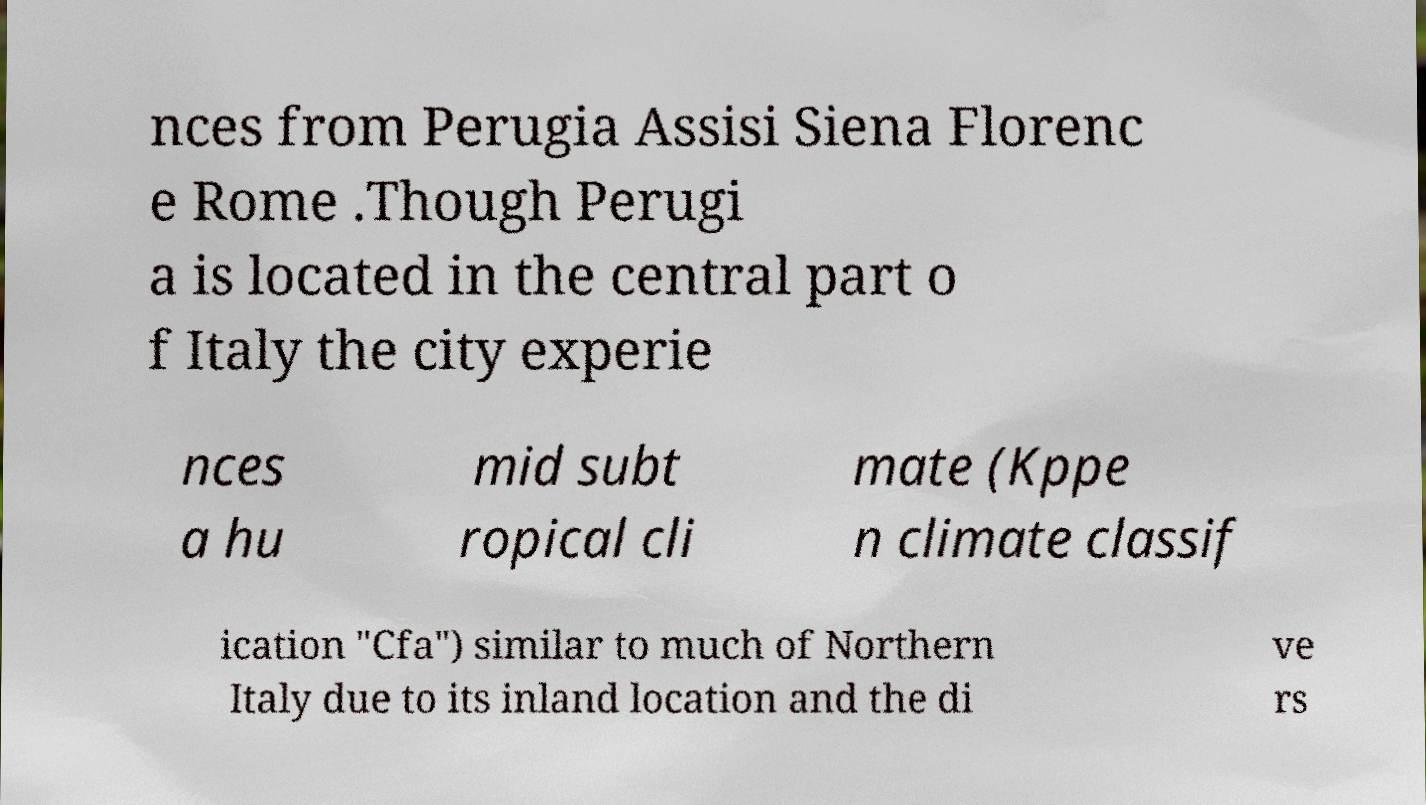What messages or text are displayed in this image? I need them in a readable, typed format. nces from Perugia Assisi Siena Florenc e Rome .Though Perugi a is located in the central part o f Italy the city experie nces a hu mid subt ropical cli mate (Kppe n climate classif ication "Cfa") similar to much of Northern Italy due to its inland location and the di ve rs 